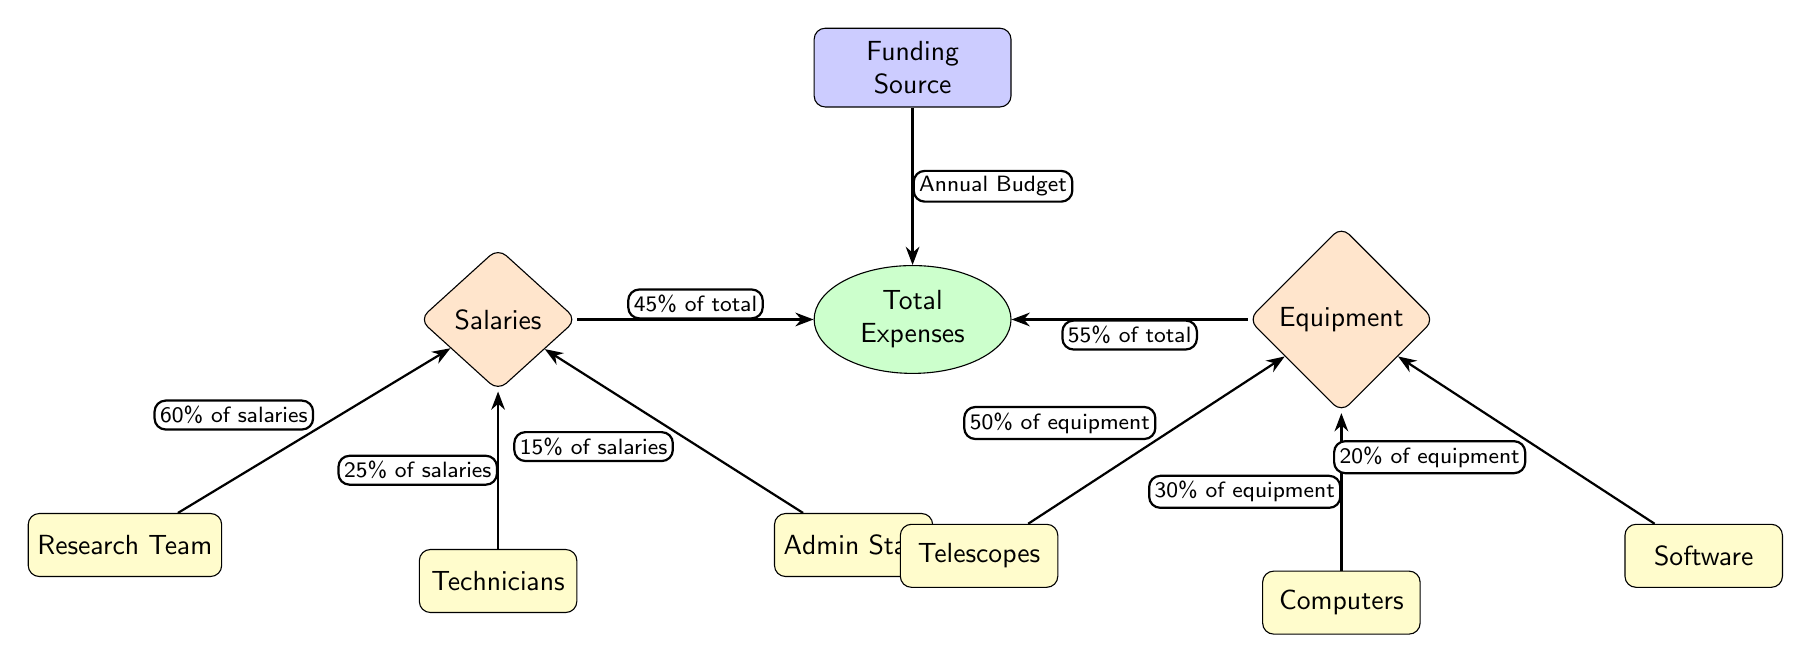What percentage of total expenses is allocated to salaries? The diagram indicates that salaries account for 45% of total expenses, as shown by the arrow connecting the salaries node to the total expenses node.
Answer: 45% What percentage of total expenses is allocated to equipment? The diagram specifies that equipment makes up 55% of total expenses, noted by the arrow leading from the equipment node to the total expenses node.
Answer: 55% How much of the salaries is spent on the research team? According to the diagram, the research team receives 60% of the salaries total, which can be seen from the arrow connecting the research team subcategory to the salaries category.
Answer: 60% Which category has a larger cost allocation, salaries or equipment? By comparing the percentages, it is clear that equipment, at 55%, has a larger allocation than salaries, which is 45%. This information can be derived from the arrows pointing to the total expenses node.
Answer: Equipment What portion of equipment expenses is dedicated to telescopes? The diagram indicates that telescopes constitute 50% of the equipment category, as denoted by the arrow connecting the telescopes subcategory to the equipment category.
Answer: 50% What are the three subcategories contributing to salary expenses? The diagram lists three subcategories under salaries: research team, technicians, and admin staff. These can be identified from the nodes directly connected to the salaries category.
Answer: Research team, Technicians, Admin Staff Which subcategory accounts for the least percentage of salaries? From the percentages, admin staff receive 15% of salaries, which is less than both the research team and technicians. This is determined by analyzing the arrows from subcategories to the salaries node.
Answer: Admin Staff What is the percentage allocation for software expenses in the equipment category? In the diagram, it's stated that software expenses constitute 20% of the equipment category, seen through the arrow indicating this percentage from the software subcategory to the equipment category.
Answer: 20% How is the total expenses calculated from salaries and equipment? The total expenses are calculated by summing the contributions from both categories: 45% from salaries and 55% from equipment, which together make up 100% of total expenses as conveyed in the divisions shown in the diagram.
Answer: 100% 